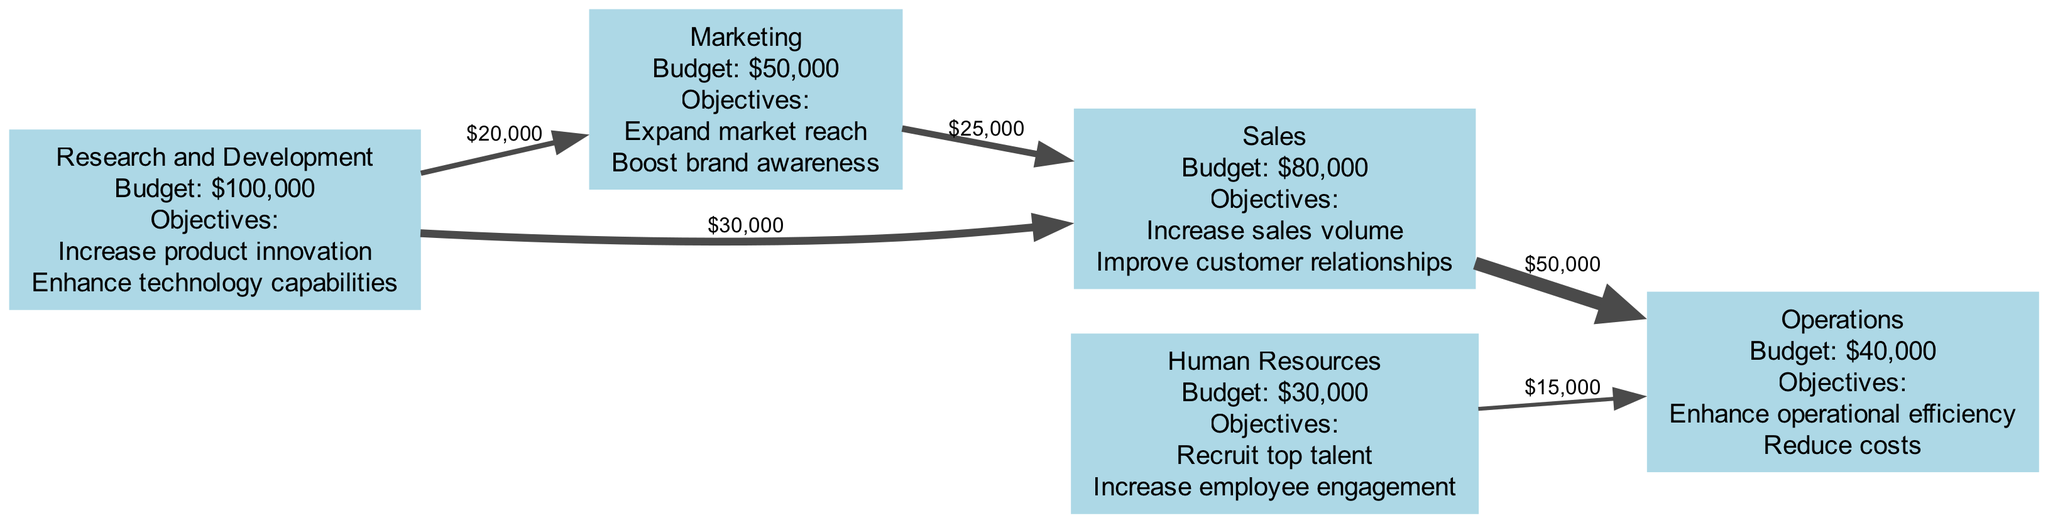What is the total budget for the Research and Development department? The diagram indicates that the budget for the Research and Development department is clearly labeled as $100,000.
Answer: $100,000 How much resource is allocated from Marketing to Sales? The flow between the Marketing and Sales departments is depicted with a label showing an amount of $25,000 being allocated. Thus, the answer is defined by this labeled flow.
Answer: $25,000 Which department receives funds from Human Resources? According to the diagram, the only flow from Human Resources goes towards Operations, which can be verified by observing the directed edge from Human Resources to Operations, clearly indicating this resource allocation.
Answer: Operations How many total departments are represented in the diagram? By counting the nodes displayed, we can specifically identify five distinct departments: Research and Development, Marketing, Sales, Human Resources, and Operations. Thus, this total count leads to the answer.
Answer: 5 What is the total resource flow from Sales to Operations? The diagram shows a flow of $50,000 from Sales to Operations. This flow is significant and represented as a directed edge that clearly indicates the resource being moved from one department to another.
Answer: $50,000 How much budget is allocated to Human Resources? The budget for Human Resources is explicitly indicated in the diagram as $30,000. This value can be easily found by looking at the node assigned for the Human Resources department.
Answer: $30,000 What is the sum of all resource flows originating from Research and Development? To calculate this, we observe the flows: $20,000 to Marketing and $30,000 to Sales. Adding these amounts ($20,000 + $30,000) gives us a total of $50,000 that flows out from Research and Development.
Answer: $50,000 How much more budget does Sales have compared to Marketing? The budget for Sales is $80,000, and for Marketing, it is $50,000. The difference can be calculated as $80,000 - $50,000, resulting in $30,000 more allocated to Sales.
Answer: $30,000 Which department has the least budget? By inspecting the budgets listed for each department, it is clear that Human Resources, with a budget of $30,000, has the least amount compared to the others displayed in the diagram.
Answer: Human Resources 